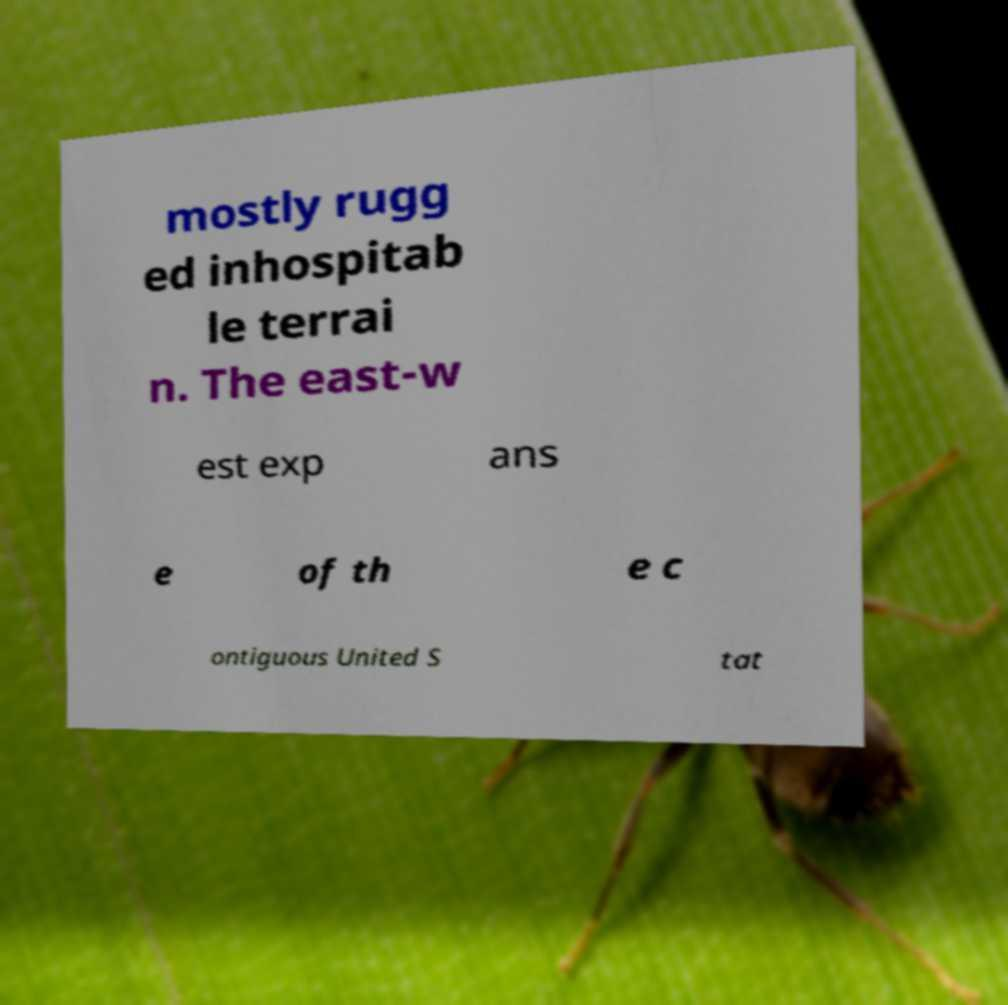For documentation purposes, I need the text within this image transcribed. Could you provide that? mostly rugg ed inhospitab le terrai n. The east-w est exp ans e of th e c ontiguous United S tat 